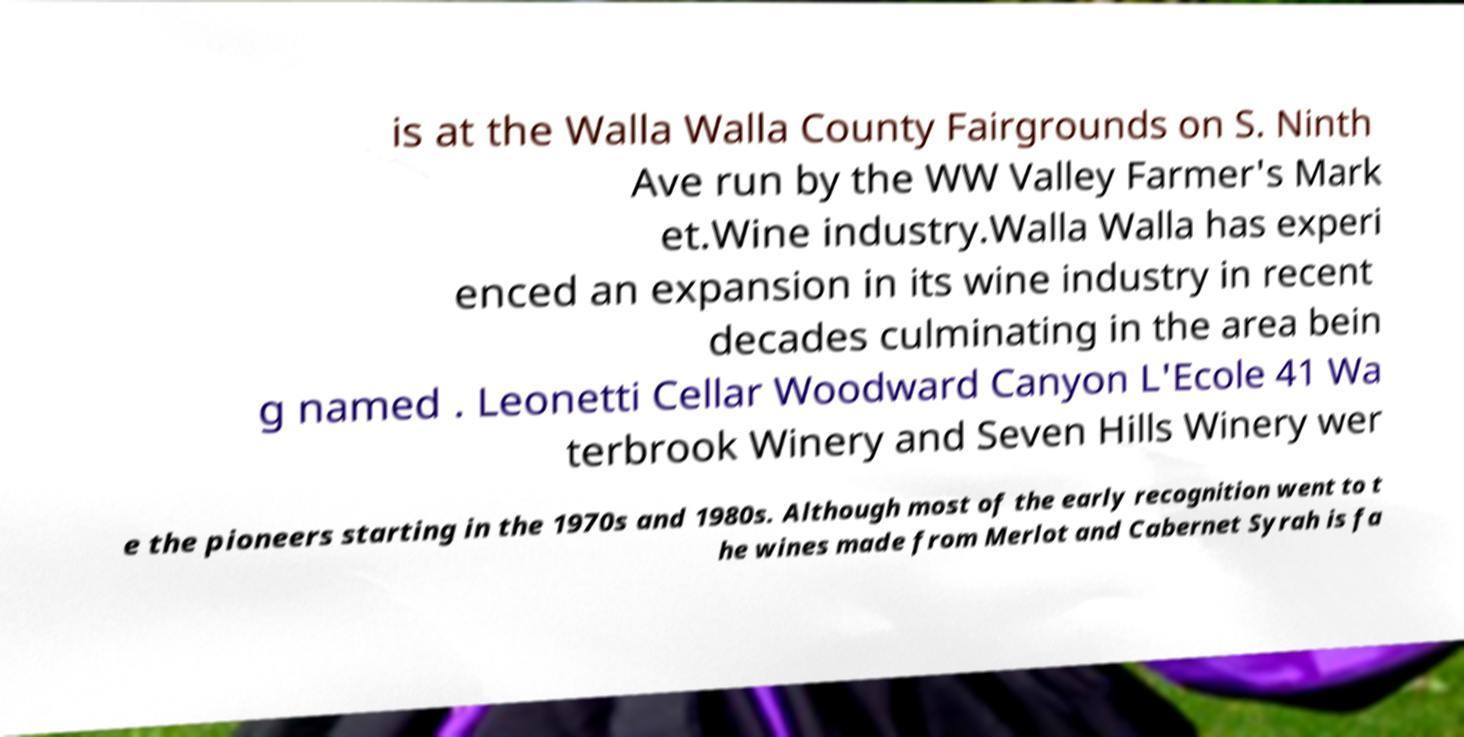Please read and relay the text visible in this image. What does it say? is at the Walla Walla County Fairgrounds on S. Ninth Ave run by the WW Valley Farmer's Mark et.Wine industry.Walla Walla has experi enced an expansion in its wine industry in recent decades culminating in the area bein g named . Leonetti Cellar Woodward Canyon L'Ecole 41 Wa terbrook Winery and Seven Hills Winery wer e the pioneers starting in the 1970s and 1980s. Although most of the early recognition went to t he wines made from Merlot and Cabernet Syrah is fa 